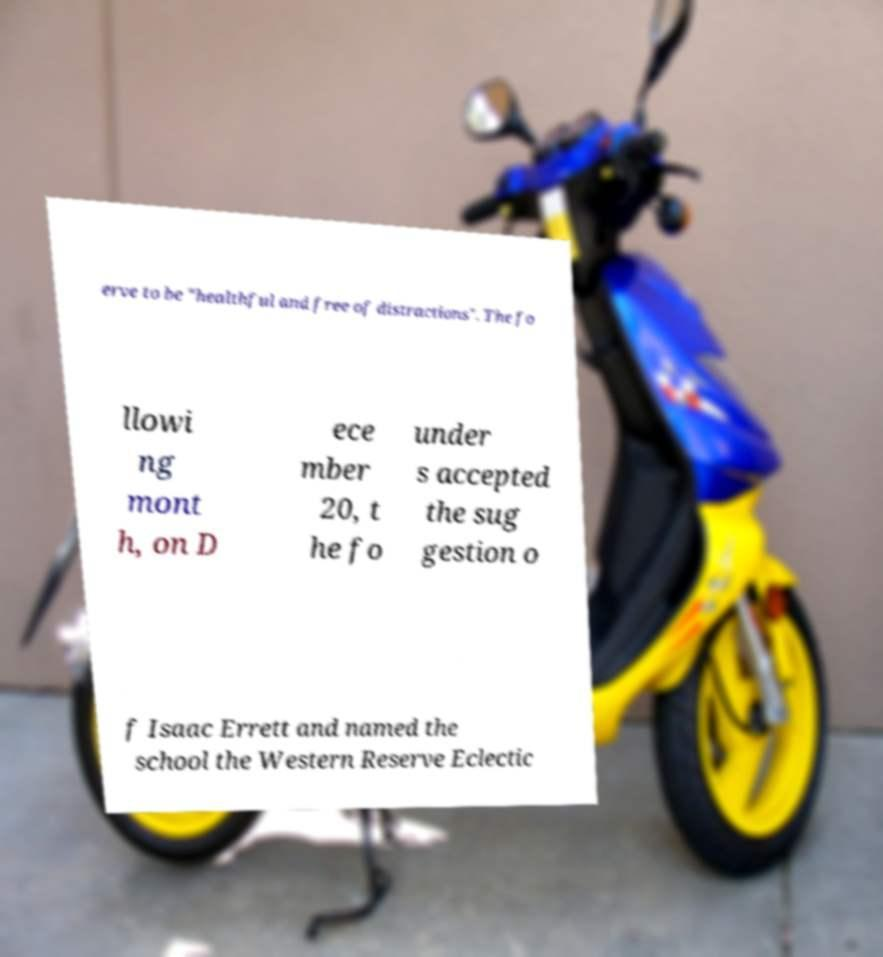Please read and relay the text visible in this image. What does it say? erve to be "healthful and free of distractions". The fo llowi ng mont h, on D ece mber 20, t he fo under s accepted the sug gestion o f Isaac Errett and named the school the Western Reserve Eclectic 